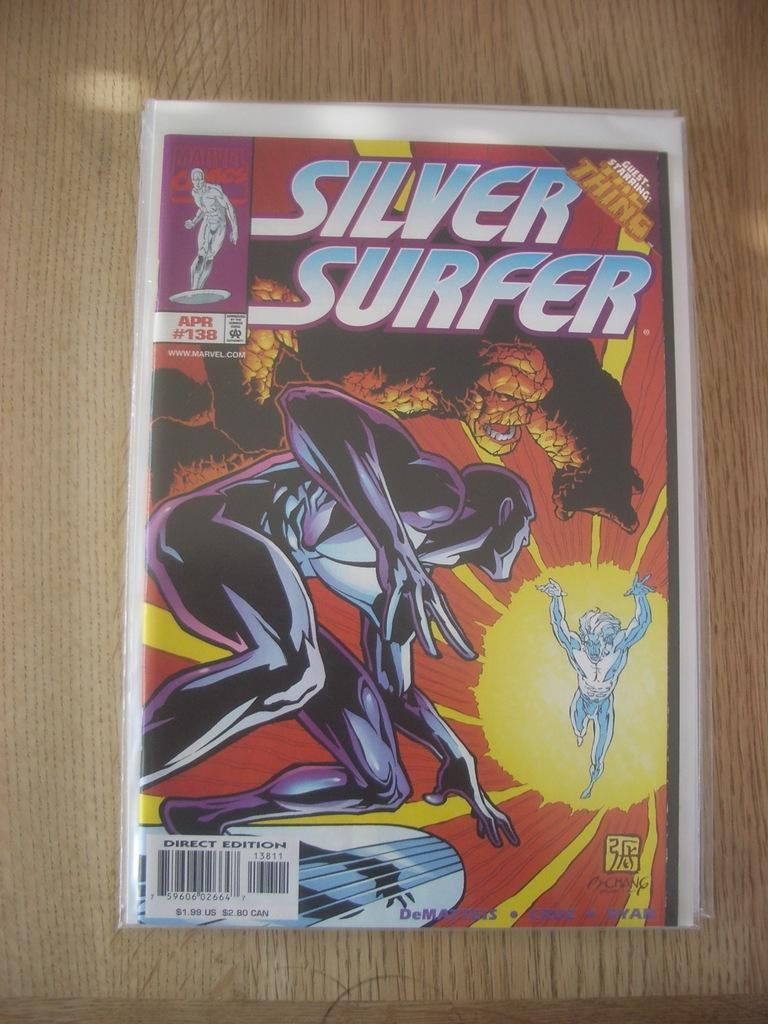<image>
Share a concise interpretation of the image provided. Silver Surfer comic book showing two superheroes fighting a villain. 